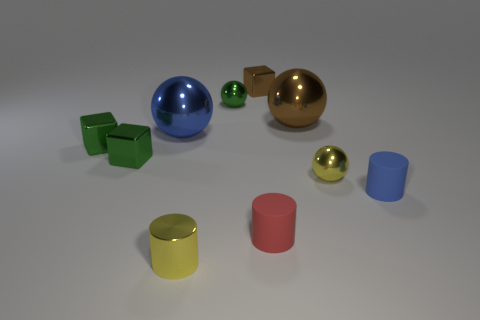What number of blue cylinders have the same material as the tiny red thing? There is one blue cylinder that has a reflective material akin to that of the tiny red cylinder. 